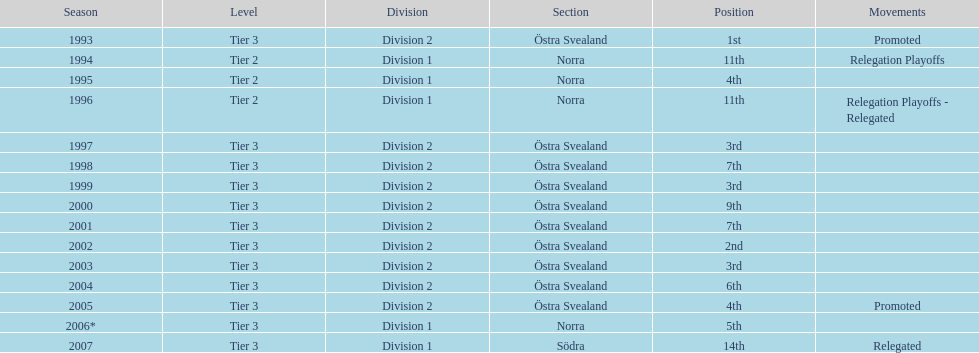How many times did they finish above 5th place in division 2 tier 3? 6. 